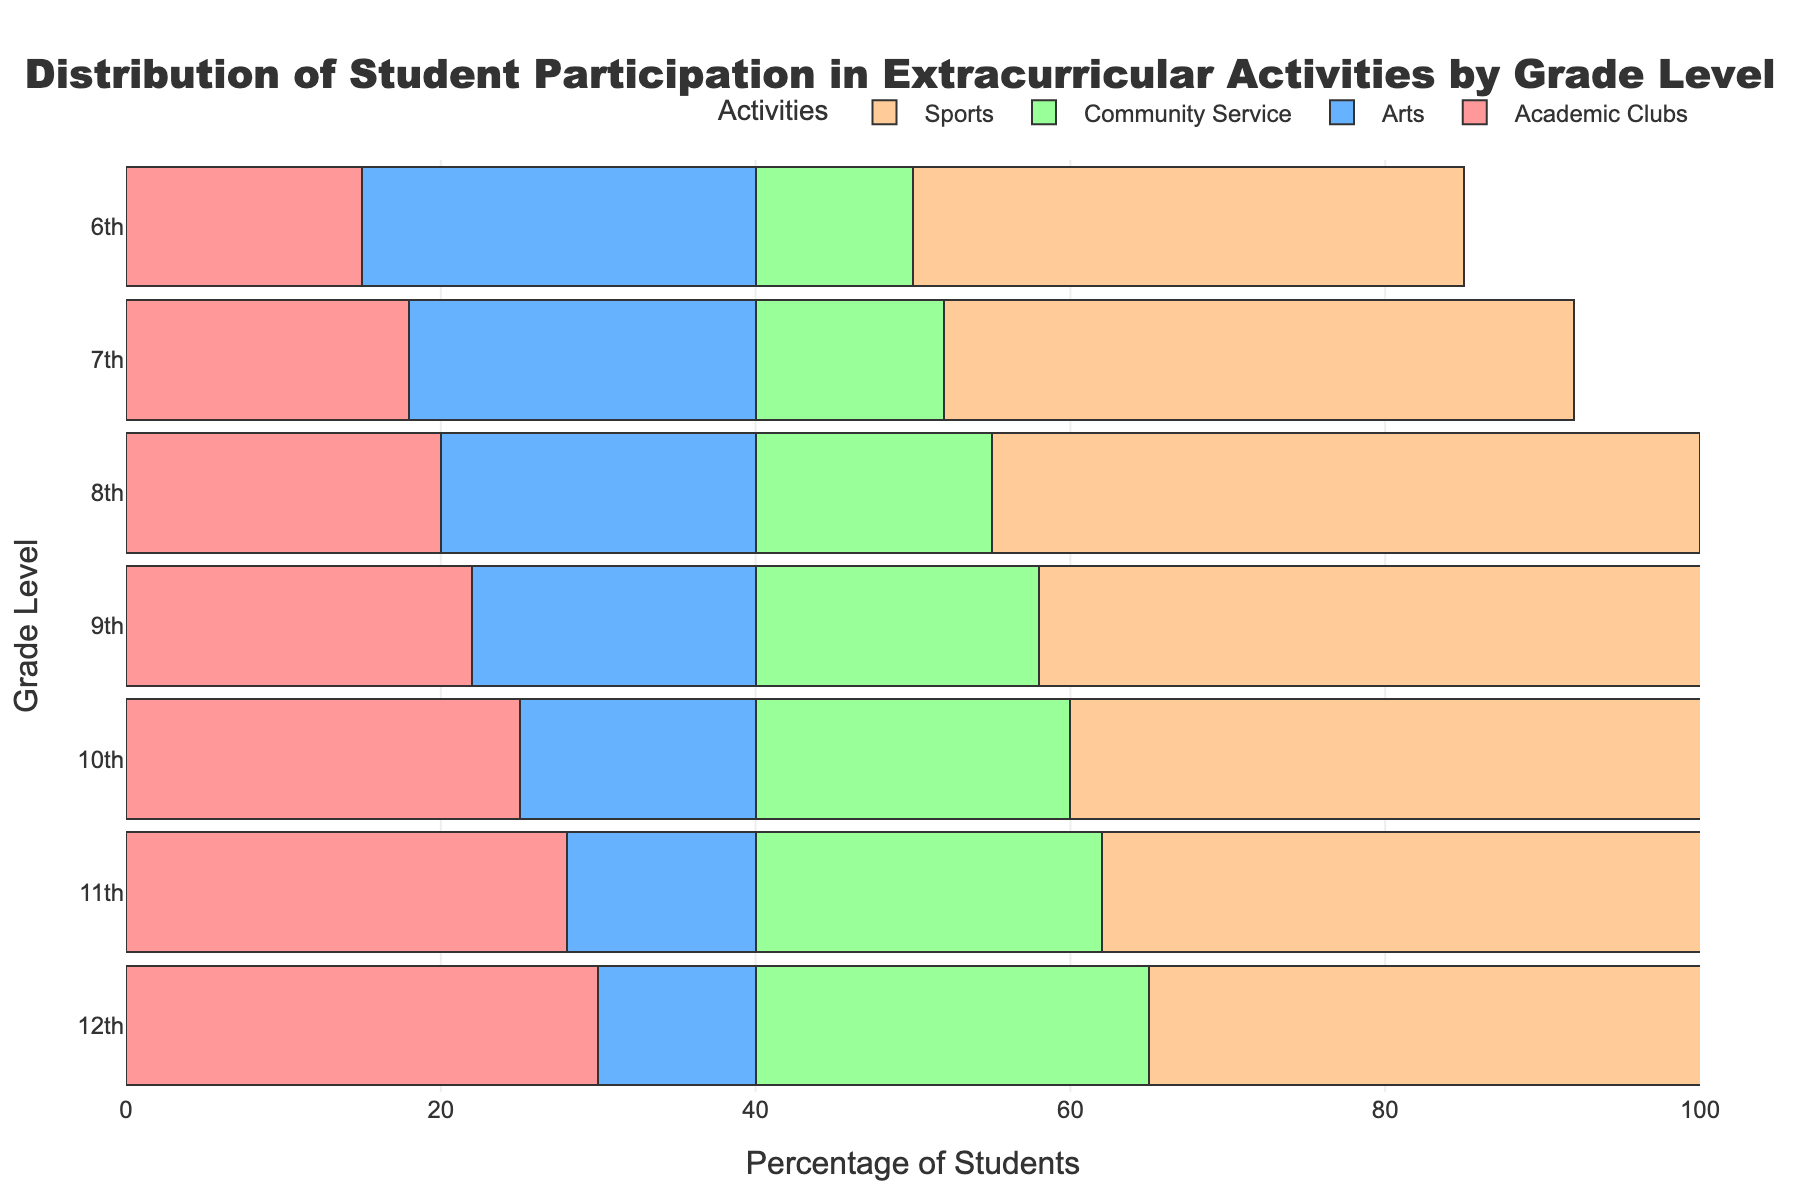What is the title of the figure? The title of the figure is typically located at the top center of the graph. For this figure, it is clearly stated just above the bar chart.
Answer: Distribution of Student Participation in Extracurricular Activities by Grade Level What does the x-axis represent? The x-axis is a horizontal line at the bottom of the graph that shows the data being measured or compared. In this figure, it represents "Percentage of Students."
Answer: Percentage of Students Which activity has the highest participation in 9th grade? To find this, look at the 9th-grade section and identify which bar extends furthest to the right. For 9th grade, the "Sports" bar is the longest.
Answer: Sports How does participation in Community Service change from 6th to 12th grade? Follow the Community Service bars from 6th to 12th grade. You will observe that participation increases as the grade level goes up, from 10% in 6th grade to 25% in 12th grade.
Answer: It increases Compare the participation in Academic Clubs between 10th and 11th grades. What do you observe? Check for the length of Academic Clubs bars for 10th and 11th grades. The 11th grade has a longer bar (28%) compared to the 10th grade (25%).
Answer: 11th grade has higher participation Which grade has the least participation in Arts? Look for the shortest bar representing Arts among all grades. The 12th grade has the shortest Arts bar at 10%.
Answer: 12th grade Which grade shows the highest overall participation in extracurricular activities? To determine this, look at which grade has the sum of all bars extending the furthest to the right. Adding up percentages for each grade, 12th grade has (40+10+30+25)=105%, which is the highest.
Answer: 12th grade Is there a trend in sports participation as students move from 6th to 12th grade? Review the Sports bars from 6th to 12th grade. Sports participation increases from 35% in 6th and peaks at 9th grade with 50%, then starts to decrease to 40% by 12th grade.
Answer: Increases initially, then decreases What’s the average participation in Academic Clubs across all grades? Add up the percentages for Academic Clubs across all grades and divide by the number of grades: (15+18+20+22+25+28+30)/7 = 22.57%.
Answer: 22.57% 